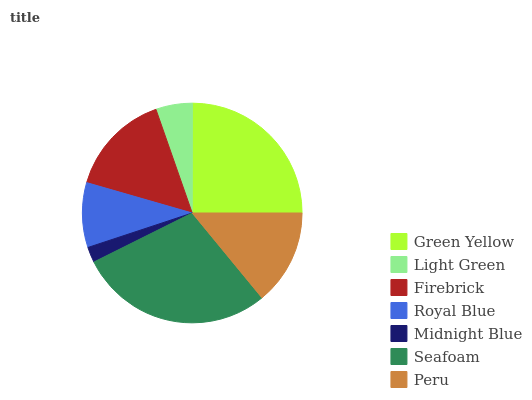Is Midnight Blue the minimum?
Answer yes or no. Yes. Is Seafoam the maximum?
Answer yes or no. Yes. Is Light Green the minimum?
Answer yes or no. No. Is Light Green the maximum?
Answer yes or no. No. Is Green Yellow greater than Light Green?
Answer yes or no. Yes. Is Light Green less than Green Yellow?
Answer yes or no. Yes. Is Light Green greater than Green Yellow?
Answer yes or no. No. Is Green Yellow less than Light Green?
Answer yes or no. No. Is Peru the high median?
Answer yes or no. Yes. Is Peru the low median?
Answer yes or no. Yes. Is Seafoam the high median?
Answer yes or no. No. Is Royal Blue the low median?
Answer yes or no. No. 